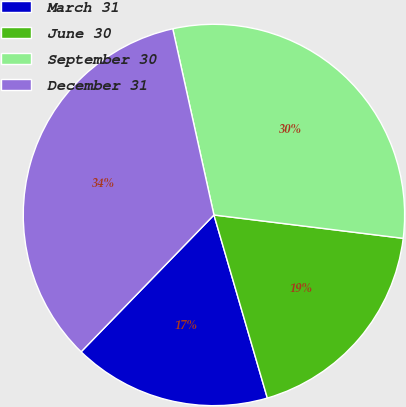Convert chart. <chart><loc_0><loc_0><loc_500><loc_500><pie_chart><fcel>March 31<fcel>June 30<fcel>September 30<fcel>December 31<nl><fcel>16.78%<fcel>18.53%<fcel>30.42%<fcel>34.27%<nl></chart> 